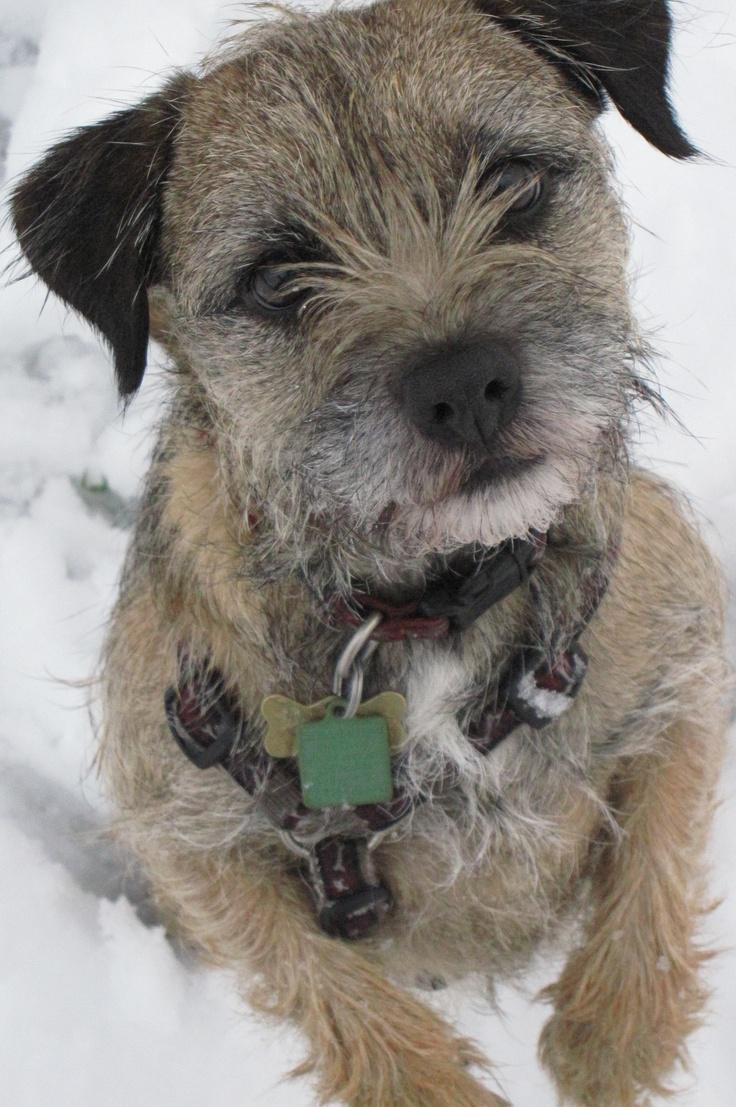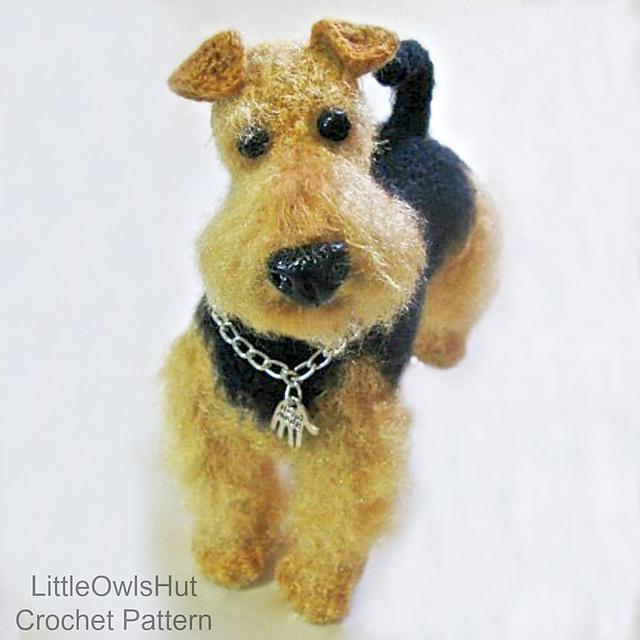The first image is the image on the left, the second image is the image on the right. Analyze the images presented: Is the assertion "A black and tan dog has snow on its face." valid? Answer yes or no. No. 